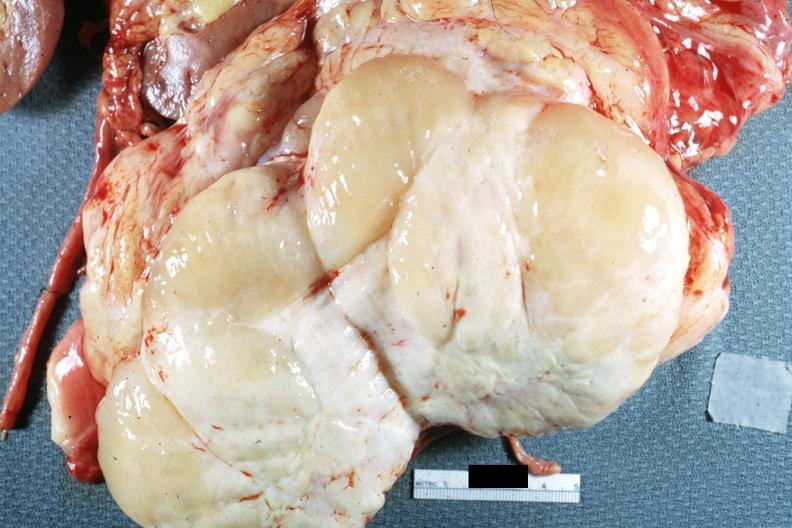where is this area in the body?
Answer the question using a single word or phrase. Abdomen 